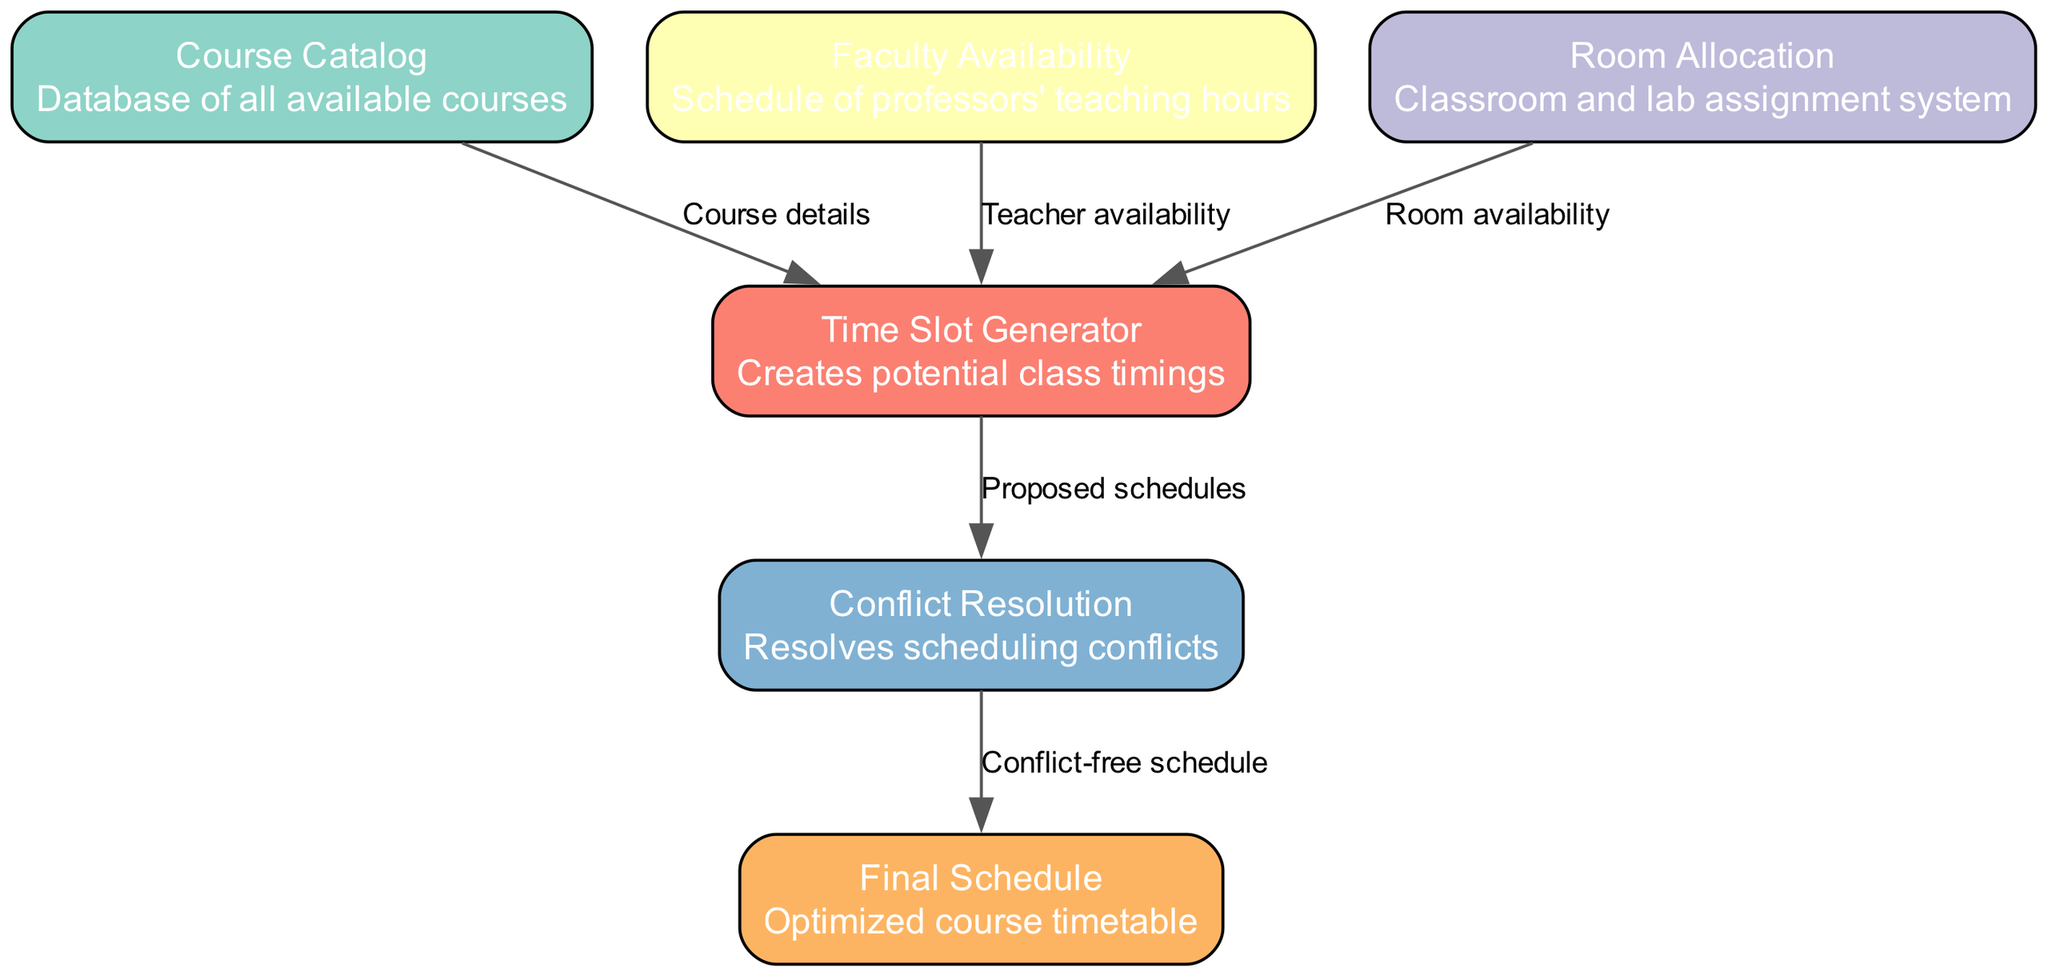What is the total number of nodes in the diagram? The diagram includes a list of nodes, which are Course Catalog, Faculty Availability, Room Allocation, Time Slot Generator, Conflict Resolution, and Final Schedule. Counting these gives a total of six nodes.
Answer: Six What is the relationship between Course Catalog and Time Slot Generator? The edge connects Course Catalog to Time Slot Generator, labeled as "Course details". This indicates that the details about courses from the Course Catalog are used to generate time slots for classes.
Answer: Course details Which node resolves scheduling conflicts? Analyzing the diagram shows that the Conflict Resolution node is specifically tasked with resolving scheduling conflicts, indicated by its direct connection to the Time Slot Generator node before finalizing the schedule.
Answer: Conflict Resolution How many edges are there in total? The diagram includes connections between nodes that represent relationships or flow of information. There are five edges: from Course Catalog to Time Slot Generator, from Faculty Availability to Time Slot Generator, from Room Allocation to Time Slot Generator, from Time Slot Generator to Conflict Resolution, and from Conflict Resolution to Final Schedule.
Answer: Five Which nodes provide input to the Time Slot Generator? The input sources to the Time Slot Generator are Course Catalog, Faculty Availability, and Room Allocation. This can be deduced from the edges leading into the Time Slot Generator from these nodes.
Answer: Course Catalog, Faculty Availability, Room Allocation What does the Final Schedule node represent? The Final Schedule node is the endpoint of the workflow, which signifies the optimized timetable after all scheduling considerations have been applied, including conflict resolutions from the previous node.
Answer: Optimized course timetable Which node is directly connected to the Conflict Resolution node? The node that is directly connected to the Conflict Resolution node is the Time Slot Generator. The edge labeled "Proposed schedules" indicates the flow of information to the Conflict Resolution node for resolving conflicts.
Answer: Time Slot Generator What information does the Faculty Availability node contribute? Faculty Availability contributes the professors' teaching hours, which are necessary for the Time Slot Generator to create viable class timings while respecting the availability of faculty members.
Answer: Teacher availability 